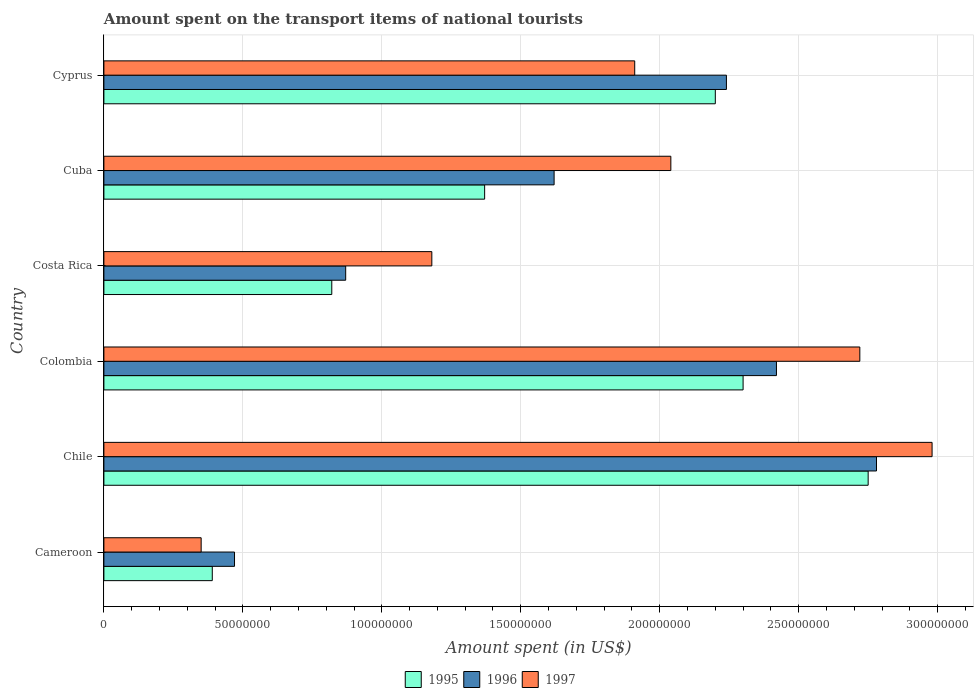How many groups of bars are there?
Your answer should be compact. 6. How many bars are there on the 3rd tick from the top?
Your answer should be very brief. 3. What is the label of the 1st group of bars from the top?
Offer a very short reply. Cyprus. What is the amount spent on the transport items of national tourists in 1997 in Cuba?
Offer a terse response. 2.04e+08. Across all countries, what is the maximum amount spent on the transport items of national tourists in 1995?
Ensure brevity in your answer.  2.75e+08. Across all countries, what is the minimum amount spent on the transport items of national tourists in 1995?
Your answer should be very brief. 3.90e+07. In which country was the amount spent on the transport items of national tourists in 1997 maximum?
Your response must be concise. Chile. In which country was the amount spent on the transport items of national tourists in 1996 minimum?
Provide a succinct answer. Cameroon. What is the total amount spent on the transport items of national tourists in 1997 in the graph?
Your answer should be compact. 1.12e+09. What is the difference between the amount spent on the transport items of national tourists in 1996 in Cameroon and that in Costa Rica?
Provide a short and direct response. -4.00e+07. What is the difference between the amount spent on the transport items of national tourists in 1997 in Cuba and the amount spent on the transport items of national tourists in 1996 in Costa Rica?
Offer a very short reply. 1.17e+08. What is the average amount spent on the transport items of national tourists in 1996 per country?
Your response must be concise. 1.73e+08. What is the difference between the amount spent on the transport items of national tourists in 1995 and amount spent on the transport items of national tourists in 1996 in Colombia?
Provide a succinct answer. -1.20e+07. What is the ratio of the amount spent on the transport items of national tourists in 1997 in Colombia to that in Cuba?
Make the answer very short. 1.33. Is the amount spent on the transport items of national tourists in 1995 in Cuba less than that in Cyprus?
Keep it short and to the point. Yes. What is the difference between the highest and the second highest amount spent on the transport items of national tourists in 1996?
Offer a terse response. 3.60e+07. What is the difference between the highest and the lowest amount spent on the transport items of national tourists in 1996?
Make the answer very short. 2.31e+08. In how many countries, is the amount spent on the transport items of national tourists in 1995 greater than the average amount spent on the transport items of national tourists in 1995 taken over all countries?
Ensure brevity in your answer.  3. What does the 1st bar from the bottom in Cyprus represents?
Make the answer very short. 1995. How many bars are there?
Give a very brief answer. 18. How many countries are there in the graph?
Provide a succinct answer. 6. What is the difference between two consecutive major ticks on the X-axis?
Your answer should be very brief. 5.00e+07. Does the graph contain any zero values?
Your answer should be compact. No. Does the graph contain grids?
Offer a terse response. Yes. How are the legend labels stacked?
Offer a terse response. Horizontal. What is the title of the graph?
Your answer should be compact. Amount spent on the transport items of national tourists. Does "1998" appear as one of the legend labels in the graph?
Make the answer very short. No. What is the label or title of the X-axis?
Provide a succinct answer. Amount spent (in US$). What is the Amount spent (in US$) in 1995 in Cameroon?
Make the answer very short. 3.90e+07. What is the Amount spent (in US$) in 1996 in Cameroon?
Your answer should be very brief. 4.70e+07. What is the Amount spent (in US$) of 1997 in Cameroon?
Offer a terse response. 3.50e+07. What is the Amount spent (in US$) of 1995 in Chile?
Make the answer very short. 2.75e+08. What is the Amount spent (in US$) in 1996 in Chile?
Keep it short and to the point. 2.78e+08. What is the Amount spent (in US$) of 1997 in Chile?
Your answer should be very brief. 2.98e+08. What is the Amount spent (in US$) of 1995 in Colombia?
Your response must be concise. 2.30e+08. What is the Amount spent (in US$) in 1996 in Colombia?
Offer a terse response. 2.42e+08. What is the Amount spent (in US$) in 1997 in Colombia?
Provide a succinct answer. 2.72e+08. What is the Amount spent (in US$) in 1995 in Costa Rica?
Provide a short and direct response. 8.20e+07. What is the Amount spent (in US$) in 1996 in Costa Rica?
Offer a terse response. 8.70e+07. What is the Amount spent (in US$) in 1997 in Costa Rica?
Ensure brevity in your answer.  1.18e+08. What is the Amount spent (in US$) in 1995 in Cuba?
Your answer should be compact. 1.37e+08. What is the Amount spent (in US$) of 1996 in Cuba?
Provide a succinct answer. 1.62e+08. What is the Amount spent (in US$) in 1997 in Cuba?
Provide a short and direct response. 2.04e+08. What is the Amount spent (in US$) in 1995 in Cyprus?
Provide a short and direct response. 2.20e+08. What is the Amount spent (in US$) in 1996 in Cyprus?
Offer a very short reply. 2.24e+08. What is the Amount spent (in US$) of 1997 in Cyprus?
Your answer should be very brief. 1.91e+08. Across all countries, what is the maximum Amount spent (in US$) of 1995?
Your answer should be very brief. 2.75e+08. Across all countries, what is the maximum Amount spent (in US$) of 1996?
Offer a very short reply. 2.78e+08. Across all countries, what is the maximum Amount spent (in US$) of 1997?
Offer a very short reply. 2.98e+08. Across all countries, what is the minimum Amount spent (in US$) in 1995?
Provide a succinct answer. 3.90e+07. Across all countries, what is the minimum Amount spent (in US$) of 1996?
Offer a very short reply. 4.70e+07. Across all countries, what is the minimum Amount spent (in US$) in 1997?
Make the answer very short. 3.50e+07. What is the total Amount spent (in US$) in 1995 in the graph?
Give a very brief answer. 9.83e+08. What is the total Amount spent (in US$) in 1996 in the graph?
Keep it short and to the point. 1.04e+09. What is the total Amount spent (in US$) in 1997 in the graph?
Provide a short and direct response. 1.12e+09. What is the difference between the Amount spent (in US$) of 1995 in Cameroon and that in Chile?
Ensure brevity in your answer.  -2.36e+08. What is the difference between the Amount spent (in US$) of 1996 in Cameroon and that in Chile?
Offer a very short reply. -2.31e+08. What is the difference between the Amount spent (in US$) in 1997 in Cameroon and that in Chile?
Provide a short and direct response. -2.63e+08. What is the difference between the Amount spent (in US$) of 1995 in Cameroon and that in Colombia?
Your answer should be compact. -1.91e+08. What is the difference between the Amount spent (in US$) in 1996 in Cameroon and that in Colombia?
Your response must be concise. -1.95e+08. What is the difference between the Amount spent (in US$) in 1997 in Cameroon and that in Colombia?
Give a very brief answer. -2.37e+08. What is the difference between the Amount spent (in US$) in 1995 in Cameroon and that in Costa Rica?
Your response must be concise. -4.30e+07. What is the difference between the Amount spent (in US$) in 1996 in Cameroon and that in Costa Rica?
Make the answer very short. -4.00e+07. What is the difference between the Amount spent (in US$) of 1997 in Cameroon and that in Costa Rica?
Provide a short and direct response. -8.30e+07. What is the difference between the Amount spent (in US$) in 1995 in Cameroon and that in Cuba?
Offer a terse response. -9.80e+07. What is the difference between the Amount spent (in US$) of 1996 in Cameroon and that in Cuba?
Your answer should be compact. -1.15e+08. What is the difference between the Amount spent (in US$) of 1997 in Cameroon and that in Cuba?
Keep it short and to the point. -1.69e+08. What is the difference between the Amount spent (in US$) of 1995 in Cameroon and that in Cyprus?
Provide a succinct answer. -1.81e+08. What is the difference between the Amount spent (in US$) of 1996 in Cameroon and that in Cyprus?
Your response must be concise. -1.77e+08. What is the difference between the Amount spent (in US$) in 1997 in Cameroon and that in Cyprus?
Provide a succinct answer. -1.56e+08. What is the difference between the Amount spent (in US$) in 1995 in Chile and that in Colombia?
Keep it short and to the point. 4.50e+07. What is the difference between the Amount spent (in US$) of 1996 in Chile and that in Colombia?
Provide a short and direct response. 3.60e+07. What is the difference between the Amount spent (in US$) in 1997 in Chile and that in Colombia?
Your response must be concise. 2.60e+07. What is the difference between the Amount spent (in US$) of 1995 in Chile and that in Costa Rica?
Provide a short and direct response. 1.93e+08. What is the difference between the Amount spent (in US$) of 1996 in Chile and that in Costa Rica?
Offer a terse response. 1.91e+08. What is the difference between the Amount spent (in US$) in 1997 in Chile and that in Costa Rica?
Your answer should be compact. 1.80e+08. What is the difference between the Amount spent (in US$) of 1995 in Chile and that in Cuba?
Ensure brevity in your answer.  1.38e+08. What is the difference between the Amount spent (in US$) in 1996 in Chile and that in Cuba?
Ensure brevity in your answer.  1.16e+08. What is the difference between the Amount spent (in US$) of 1997 in Chile and that in Cuba?
Provide a short and direct response. 9.40e+07. What is the difference between the Amount spent (in US$) in 1995 in Chile and that in Cyprus?
Your response must be concise. 5.50e+07. What is the difference between the Amount spent (in US$) of 1996 in Chile and that in Cyprus?
Ensure brevity in your answer.  5.40e+07. What is the difference between the Amount spent (in US$) in 1997 in Chile and that in Cyprus?
Offer a terse response. 1.07e+08. What is the difference between the Amount spent (in US$) in 1995 in Colombia and that in Costa Rica?
Ensure brevity in your answer.  1.48e+08. What is the difference between the Amount spent (in US$) in 1996 in Colombia and that in Costa Rica?
Offer a terse response. 1.55e+08. What is the difference between the Amount spent (in US$) of 1997 in Colombia and that in Costa Rica?
Provide a succinct answer. 1.54e+08. What is the difference between the Amount spent (in US$) in 1995 in Colombia and that in Cuba?
Your answer should be compact. 9.30e+07. What is the difference between the Amount spent (in US$) in 1996 in Colombia and that in Cuba?
Your response must be concise. 8.00e+07. What is the difference between the Amount spent (in US$) in 1997 in Colombia and that in Cuba?
Your answer should be compact. 6.80e+07. What is the difference between the Amount spent (in US$) of 1996 in Colombia and that in Cyprus?
Offer a terse response. 1.80e+07. What is the difference between the Amount spent (in US$) of 1997 in Colombia and that in Cyprus?
Give a very brief answer. 8.10e+07. What is the difference between the Amount spent (in US$) of 1995 in Costa Rica and that in Cuba?
Give a very brief answer. -5.50e+07. What is the difference between the Amount spent (in US$) in 1996 in Costa Rica and that in Cuba?
Provide a succinct answer. -7.50e+07. What is the difference between the Amount spent (in US$) in 1997 in Costa Rica and that in Cuba?
Make the answer very short. -8.60e+07. What is the difference between the Amount spent (in US$) in 1995 in Costa Rica and that in Cyprus?
Your answer should be very brief. -1.38e+08. What is the difference between the Amount spent (in US$) in 1996 in Costa Rica and that in Cyprus?
Provide a succinct answer. -1.37e+08. What is the difference between the Amount spent (in US$) in 1997 in Costa Rica and that in Cyprus?
Your answer should be compact. -7.30e+07. What is the difference between the Amount spent (in US$) in 1995 in Cuba and that in Cyprus?
Your answer should be very brief. -8.30e+07. What is the difference between the Amount spent (in US$) in 1996 in Cuba and that in Cyprus?
Your response must be concise. -6.20e+07. What is the difference between the Amount spent (in US$) in 1997 in Cuba and that in Cyprus?
Make the answer very short. 1.30e+07. What is the difference between the Amount spent (in US$) of 1995 in Cameroon and the Amount spent (in US$) of 1996 in Chile?
Provide a succinct answer. -2.39e+08. What is the difference between the Amount spent (in US$) in 1995 in Cameroon and the Amount spent (in US$) in 1997 in Chile?
Keep it short and to the point. -2.59e+08. What is the difference between the Amount spent (in US$) of 1996 in Cameroon and the Amount spent (in US$) of 1997 in Chile?
Offer a very short reply. -2.51e+08. What is the difference between the Amount spent (in US$) in 1995 in Cameroon and the Amount spent (in US$) in 1996 in Colombia?
Give a very brief answer. -2.03e+08. What is the difference between the Amount spent (in US$) in 1995 in Cameroon and the Amount spent (in US$) in 1997 in Colombia?
Offer a terse response. -2.33e+08. What is the difference between the Amount spent (in US$) of 1996 in Cameroon and the Amount spent (in US$) of 1997 in Colombia?
Provide a short and direct response. -2.25e+08. What is the difference between the Amount spent (in US$) of 1995 in Cameroon and the Amount spent (in US$) of 1996 in Costa Rica?
Give a very brief answer. -4.80e+07. What is the difference between the Amount spent (in US$) in 1995 in Cameroon and the Amount spent (in US$) in 1997 in Costa Rica?
Offer a very short reply. -7.90e+07. What is the difference between the Amount spent (in US$) in 1996 in Cameroon and the Amount spent (in US$) in 1997 in Costa Rica?
Provide a succinct answer. -7.10e+07. What is the difference between the Amount spent (in US$) of 1995 in Cameroon and the Amount spent (in US$) of 1996 in Cuba?
Your answer should be compact. -1.23e+08. What is the difference between the Amount spent (in US$) in 1995 in Cameroon and the Amount spent (in US$) in 1997 in Cuba?
Give a very brief answer. -1.65e+08. What is the difference between the Amount spent (in US$) in 1996 in Cameroon and the Amount spent (in US$) in 1997 in Cuba?
Keep it short and to the point. -1.57e+08. What is the difference between the Amount spent (in US$) of 1995 in Cameroon and the Amount spent (in US$) of 1996 in Cyprus?
Your answer should be compact. -1.85e+08. What is the difference between the Amount spent (in US$) in 1995 in Cameroon and the Amount spent (in US$) in 1997 in Cyprus?
Ensure brevity in your answer.  -1.52e+08. What is the difference between the Amount spent (in US$) of 1996 in Cameroon and the Amount spent (in US$) of 1997 in Cyprus?
Your answer should be compact. -1.44e+08. What is the difference between the Amount spent (in US$) in 1995 in Chile and the Amount spent (in US$) in 1996 in Colombia?
Your response must be concise. 3.30e+07. What is the difference between the Amount spent (in US$) in 1996 in Chile and the Amount spent (in US$) in 1997 in Colombia?
Provide a short and direct response. 6.00e+06. What is the difference between the Amount spent (in US$) of 1995 in Chile and the Amount spent (in US$) of 1996 in Costa Rica?
Keep it short and to the point. 1.88e+08. What is the difference between the Amount spent (in US$) of 1995 in Chile and the Amount spent (in US$) of 1997 in Costa Rica?
Provide a short and direct response. 1.57e+08. What is the difference between the Amount spent (in US$) of 1996 in Chile and the Amount spent (in US$) of 1997 in Costa Rica?
Make the answer very short. 1.60e+08. What is the difference between the Amount spent (in US$) in 1995 in Chile and the Amount spent (in US$) in 1996 in Cuba?
Your answer should be compact. 1.13e+08. What is the difference between the Amount spent (in US$) of 1995 in Chile and the Amount spent (in US$) of 1997 in Cuba?
Give a very brief answer. 7.10e+07. What is the difference between the Amount spent (in US$) of 1996 in Chile and the Amount spent (in US$) of 1997 in Cuba?
Your answer should be very brief. 7.40e+07. What is the difference between the Amount spent (in US$) in 1995 in Chile and the Amount spent (in US$) in 1996 in Cyprus?
Make the answer very short. 5.10e+07. What is the difference between the Amount spent (in US$) of 1995 in Chile and the Amount spent (in US$) of 1997 in Cyprus?
Offer a very short reply. 8.40e+07. What is the difference between the Amount spent (in US$) of 1996 in Chile and the Amount spent (in US$) of 1997 in Cyprus?
Provide a succinct answer. 8.70e+07. What is the difference between the Amount spent (in US$) of 1995 in Colombia and the Amount spent (in US$) of 1996 in Costa Rica?
Offer a very short reply. 1.43e+08. What is the difference between the Amount spent (in US$) in 1995 in Colombia and the Amount spent (in US$) in 1997 in Costa Rica?
Give a very brief answer. 1.12e+08. What is the difference between the Amount spent (in US$) of 1996 in Colombia and the Amount spent (in US$) of 1997 in Costa Rica?
Keep it short and to the point. 1.24e+08. What is the difference between the Amount spent (in US$) of 1995 in Colombia and the Amount spent (in US$) of 1996 in Cuba?
Ensure brevity in your answer.  6.80e+07. What is the difference between the Amount spent (in US$) in 1995 in Colombia and the Amount spent (in US$) in 1997 in Cuba?
Offer a terse response. 2.60e+07. What is the difference between the Amount spent (in US$) in 1996 in Colombia and the Amount spent (in US$) in 1997 in Cuba?
Offer a terse response. 3.80e+07. What is the difference between the Amount spent (in US$) of 1995 in Colombia and the Amount spent (in US$) of 1996 in Cyprus?
Your answer should be very brief. 6.00e+06. What is the difference between the Amount spent (in US$) in 1995 in Colombia and the Amount spent (in US$) in 1997 in Cyprus?
Ensure brevity in your answer.  3.90e+07. What is the difference between the Amount spent (in US$) of 1996 in Colombia and the Amount spent (in US$) of 1997 in Cyprus?
Provide a short and direct response. 5.10e+07. What is the difference between the Amount spent (in US$) of 1995 in Costa Rica and the Amount spent (in US$) of 1996 in Cuba?
Give a very brief answer. -8.00e+07. What is the difference between the Amount spent (in US$) of 1995 in Costa Rica and the Amount spent (in US$) of 1997 in Cuba?
Give a very brief answer. -1.22e+08. What is the difference between the Amount spent (in US$) in 1996 in Costa Rica and the Amount spent (in US$) in 1997 in Cuba?
Keep it short and to the point. -1.17e+08. What is the difference between the Amount spent (in US$) in 1995 in Costa Rica and the Amount spent (in US$) in 1996 in Cyprus?
Ensure brevity in your answer.  -1.42e+08. What is the difference between the Amount spent (in US$) of 1995 in Costa Rica and the Amount spent (in US$) of 1997 in Cyprus?
Offer a very short reply. -1.09e+08. What is the difference between the Amount spent (in US$) of 1996 in Costa Rica and the Amount spent (in US$) of 1997 in Cyprus?
Provide a short and direct response. -1.04e+08. What is the difference between the Amount spent (in US$) in 1995 in Cuba and the Amount spent (in US$) in 1996 in Cyprus?
Offer a terse response. -8.70e+07. What is the difference between the Amount spent (in US$) of 1995 in Cuba and the Amount spent (in US$) of 1997 in Cyprus?
Provide a short and direct response. -5.40e+07. What is the difference between the Amount spent (in US$) of 1996 in Cuba and the Amount spent (in US$) of 1997 in Cyprus?
Offer a very short reply. -2.90e+07. What is the average Amount spent (in US$) in 1995 per country?
Give a very brief answer. 1.64e+08. What is the average Amount spent (in US$) in 1996 per country?
Offer a very short reply. 1.73e+08. What is the average Amount spent (in US$) in 1997 per country?
Offer a very short reply. 1.86e+08. What is the difference between the Amount spent (in US$) of 1995 and Amount spent (in US$) of 1996 in Cameroon?
Ensure brevity in your answer.  -8.00e+06. What is the difference between the Amount spent (in US$) of 1995 and Amount spent (in US$) of 1997 in Cameroon?
Your answer should be compact. 4.00e+06. What is the difference between the Amount spent (in US$) of 1995 and Amount spent (in US$) of 1997 in Chile?
Keep it short and to the point. -2.30e+07. What is the difference between the Amount spent (in US$) in 1996 and Amount spent (in US$) in 1997 in Chile?
Your answer should be very brief. -2.00e+07. What is the difference between the Amount spent (in US$) of 1995 and Amount spent (in US$) of 1996 in Colombia?
Ensure brevity in your answer.  -1.20e+07. What is the difference between the Amount spent (in US$) of 1995 and Amount spent (in US$) of 1997 in Colombia?
Offer a very short reply. -4.20e+07. What is the difference between the Amount spent (in US$) in 1996 and Amount spent (in US$) in 1997 in Colombia?
Provide a short and direct response. -3.00e+07. What is the difference between the Amount spent (in US$) of 1995 and Amount spent (in US$) of 1996 in Costa Rica?
Offer a very short reply. -5.00e+06. What is the difference between the Amount spent (in US$) of 1995 and Amount spent (in US$) of 1997 in Costa Rica?
Provide a succinct answer. -3.60e+07. What is the difference between the Amount spent (in US$) in 1996 and Amount spent (in US$) in 1997 in Costa Rica?
Give a very brief answer. -3.10e+07. What is the difference between the Amount spent (in US$) of 1995 and Amount spent (in US$) of 1996 in Cuba?
Keep it short and to the point. -2.50e+07. What is the difference between the Amount spent (in US$) of 1995 and Amount spent (in US$) of 1997 in Cuba?
Keep it short and to the point. -6.70e+07. What is the difference between the Amount spent (in US$) in 1996 and Amount spent (in US$) in 1997 in Cuba?
Make the answer very short. -4.20e+07. What is the difference between the Amount spent (in US$) in 1995 and Amount spent (in US$) in 1996 in Cyprus?
Offer a terse response. -4.00e+06. What is the difference between the Amount spent (in US$) of 1995 and Amount spent (in US$) of 1997 in Cyprus?
Give a very brief answer. 2.90e+07. What is the difference between the Amount spent (in US$) in 1996 and Amount spent (in US$) in 1997 in Cyprus?
Provide a succinct answer. 3.30e+07. What is the ratio of the Amount spent (in US$) in 1995 in Cameroon to that in Chile?
Keep it short and to the point. 0.14. What is the ratio of the Amount spent (in US$) in 1996 in Cameroon to that in Chile?
Keep it short and to the point. 0.17. What is the ratio of the Amount spent (in US$) of 1997 in Cameroon to that in Chile?
Your answer should be very brief. 0.12. What is the ratio of the Amount spent (in US$) in 1995 in Cameroon to that in Colombia?
Provide a short and direct response. 0.17. What is the ratio of the Amount spent (in US$) in 1996 in Cameroon to that in Colombia?
Your answer should be compact. 0.19. What is the ratio of the Amount spent (in US$) in 1997 in Cameroon to that in Colombia?
Offer a very short reply. 0.13. What is the ratio of the Amount spent (in US$) in 1995 in Cameroon to that in Costa Rica?
Your answer should be very brief. 0.48. What is the ratio of the Amount spent (in US$) of 1996 in Cameroon to that in Costa Rica?
Offer a very short reply. 0.54. What is the ratio of the Amount spent (in US$) in 1997 in Cameroon to that in Costa Rica?
Ensure brevity in your answer.  0.3. What is the ratio of the Amount spent (in US$) in 1995 in Cameroon to that in Cuba?
Offer a very short reply. 0.28. What is the ratio of the Amount spent (in US$) of 1996 in Cameroon to that in Cuba?
Ensure brevity in your answer.  0.29. What is the ratio of the Amount spent (in US$) of 1997 in Cameroon to that in Cuba?
Your answer should be very brief. 0.17. What is the ratio of the Amount spent (in US$) of 1995 in Cameroon to that in Cyprus?
Ensure brevity in your answer.  0.18. What is the ratio of the Amount spent (in US$) of 1996 in Cameroon to that in Cyprus?
Ensure brevity in your answer.  0.21. What is the ratio of the Amount spent (in US$) of 1997 in Cameroon to that in Cyprus?
Your answer should be very brief. 0.18. What is the ratio of the Amount spent (in US$) in 1995 in Chile to that in Colombia?
Offer a very short reply. 1.2. What is the ratio of the Amount spent (in US$) of 1996 in Chile to that in Colombia?
Provide a succinct answer. 1.15. What is the ratio of the Amount spent (in US$) of 1997 in Chile to that in Colombia?
Offer a terse response. 1.1. What is the ratio of the Amount spent (in US$) in 1995 in Chile to that in Costa Rica?
Your answer should be compact. 3.35. What is the ratio of the Amount spent (in US$) in 1996 in Chile to that in Costa Rica?
Keep it short and to the point. 3.2. What is the ratio of the Amount spent (in US$) in 1997 in Chile to that in Costa Rica?
Keep it short and to the point. 2.53. What is the ratio of the Amount spent (in US$) in 1995 in Chile to that in Cuba?
Ensure brevity in your answer.  2.01. What is the ratio of the Amount spent (in US$) of 1996 in Chile to that in Cuba?
Your answer should be very brief. 1.72. What is the ratio of the Amount spent (in US$) in 1997 in Chile to that in Cuba?
Your response must be concise. 1.46. What is the ratio of the Amount spent (in US$) of 1996 in Chile to that in Cyprus?
Ensure brevity in your answer.  1.24. What is the ratio of the Amount spent (in US$) in 1997 in Chile to that in Cyprus?
Provide a short and direct response. 1.56. What is the ratio of the Amount spent (in US$) in 1995 in Colombia to that in Costa Rica?
Offer a terse response. 2.8. What is the ratio of the Amount spent (in US$) of 1996 in Colombia to that in Costa Rica?
Your response must be concise. 2.78. What is the ratio of the Amount spent (in US$) in 1997 in Colombia to that in Costa Rica?
Your answer should be very brief. 2.31. What is the ratio of the Amount spent (in US$) in 1995 in Colombia to that in Cuba?
Offer a terse response. 1.68. What is the ratio of the Amount spent (in US$) of 1996 in Colombia to that in Cuba?
Give a very brief answer. 1.49. What is the ratio of the Amount spent (in US$) of 1997 in Colombia to that in Cuba?
Provide a short and direct response. 1.33. What is the ratio of the Amount spent (in US$) of 1995 in Colombia to that in Cyprus?
Keep it short and to the point. 1.05. What is the ratio of the Amount spent (in US$) in 1996 in Colombia to that in Cyprus?
Give a very brief answer. 1.08. What is the ratio of the Amount spent (in US$) of 1997 in Colombia to that in Cyprus?
Ensure brevity in your answer.  1.42. What is the ratio of the Amount spent (in US$) of 1995 in Costa Rica to that in Cuba?
Provide a succinct answer. 0.6. What is the ratio of the Amount spent (in US$) in 1996 in Costa Rica to that in Cuba?
Make the answer very short. 0.54. What is the ratio of the Amount spent (in US$) of 1997 in Costa Rica to that in Cuba?
Keep it short and to the point. 0.58. What is the ratio of the Amount spent (in US$) in 1995 in Costa Rica to that in Cyprus?
Your response must be concise. 0.37. What is the ratio of the Amount spent (in US$) of 1996 in Costa Rica to that in Cyprus?
Make the answer very short. 0.39. What is the ratio of the Amount spent (in US$) of 1997 in Costa Rica to that in Cyprus?
Your answer should be very brief. 0.62. What is the ratio of the Amount spent (in US$) in 1995 in Cuba to that in Cyprus?
Keep it short and to the point. 0.62. What is the ratio of the Amount spent (in US$) of 1996 in Cuba to that in Cyprus?
Your answer should be very brief. 0.72. What is the ratio of the Amount spent (in US$) of 1997 in Cuba to that in Cyprus?
Give a very brief answer. 1.07. What is the difference between the highest and the second highest Amount spent (in US$) in 1995?
Give a very brief answer. 4.50e+07. What is the difference between the highest and the second highest Amount spent (in US$) of 1996?
Provide a succinct answer. 3.60e+07. What is the difference between the highest and the second highest Amount spent (in US$) of 1997?
Your answer should be very brief. 2.60e+07. What is the difference between the highest and the lowest Amount spent (in US$) in 1995?
Offer a very short reply. 2.36e+08. What is the difference between the highest and the lowest Amount spent (in US$) of 1996?
Your answer should be compact. 2.31e+08. What is the difference between the highest and the lowest Amount spent (in US$) in 1997?
Provide a succinct answer. 2.63e+08. 